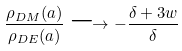<formula> <loc_0><loc_0><loc_500><loc_500>\frac { \rho _ { D M } ( a ) } { \rho _ { D E } ( a ) } \longrightarrow - \frac { \delta + 3 w } { \delta }</formula> 